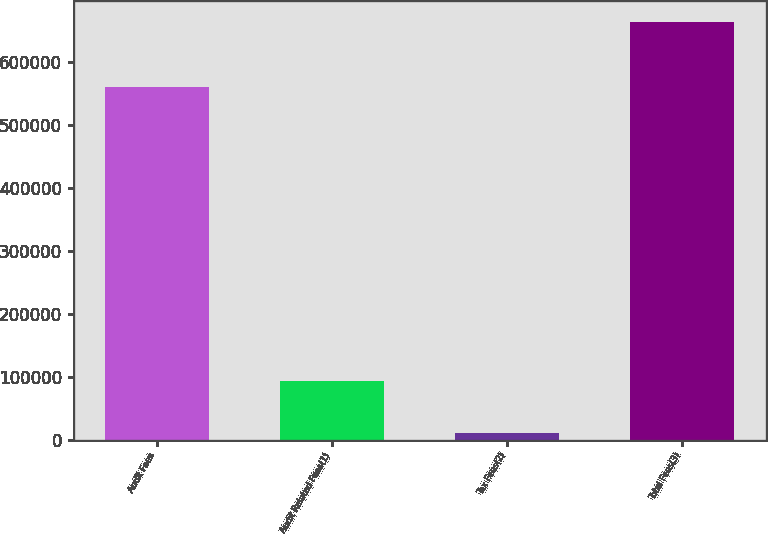<chart> <loc_0><loc_0><loc_500><loc_500><bar_chart><fcel>Audit Fees<fcel>Audit Related Fees(1)<fcel>Tax Fees(2)<fcel>Total Fees(3)<nl><fcel>559572<fcel>93830<fcel>10383<fcel>663785<nl></chart> 